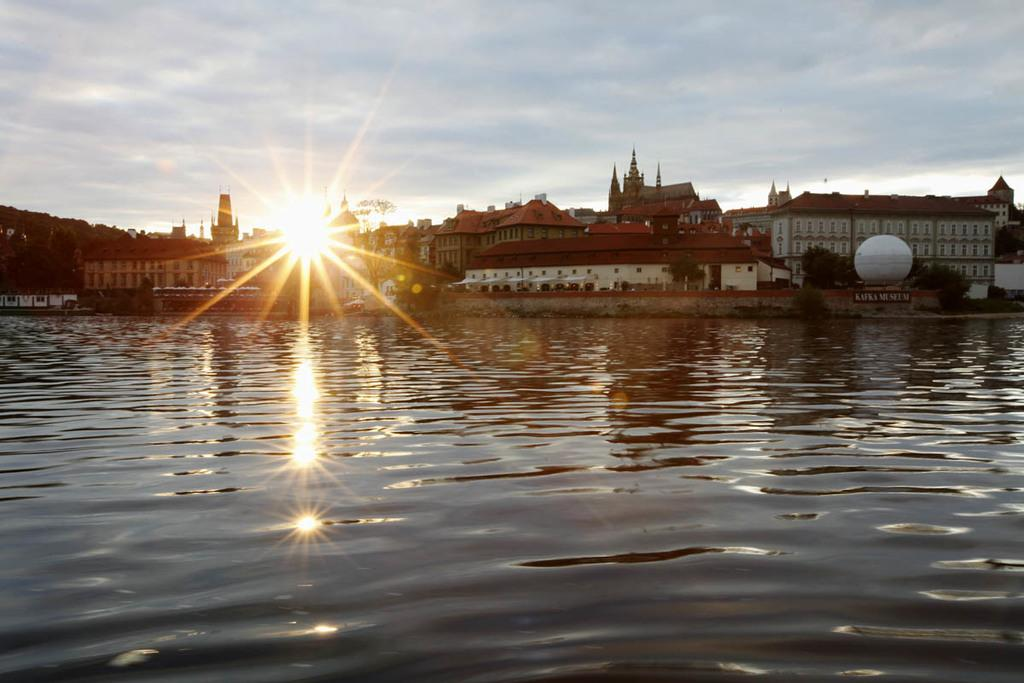What is the primary element visible in the image? There is water in the image. What type of structure can be seen in the image? There is a house in the image. Are there any other structures besides the house? Yes, there are buildings in the image. What can be seen in the sky in the image? The sun and clouds are visible in the image. What is the color of the sky in the image? The sky is visible in the image, but the color is not mentioned in the facts. How many friends are playing with the pigs in the image? There are no friends or pigs present in the image. 